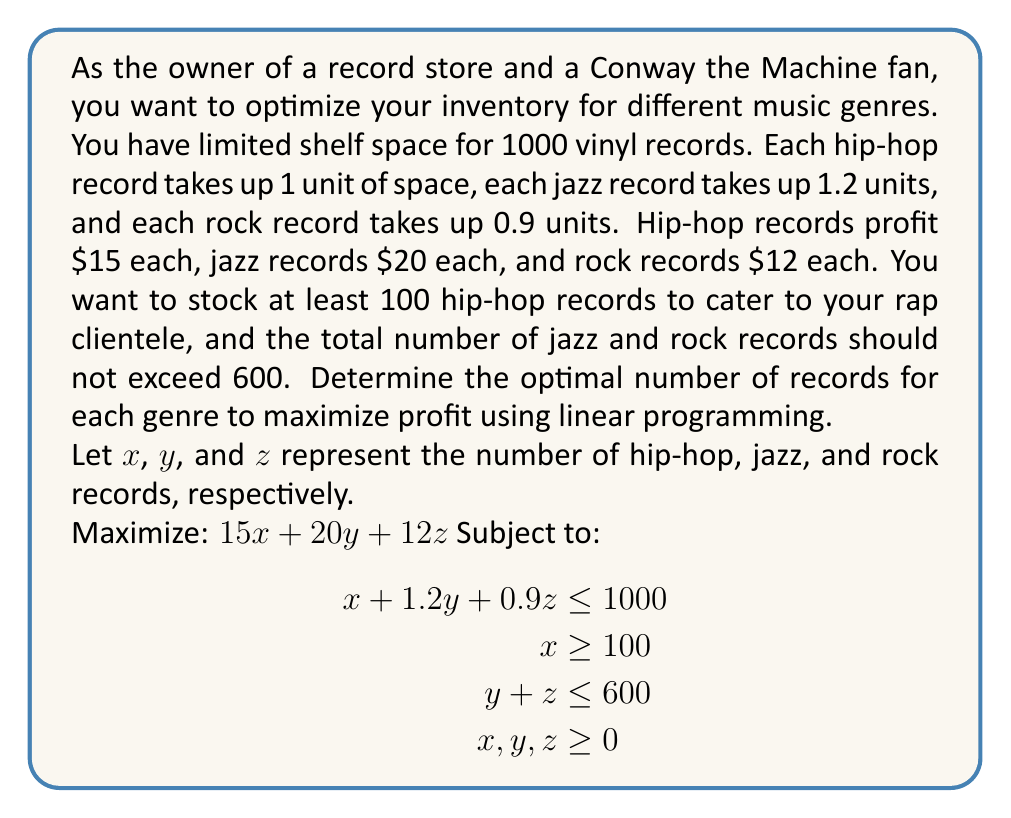Help me with this question. To solve this linear programming problem, we'll use the simplex method:

1. Convert inequalities to equations by introducing slack variables:
   $$\begin{align}
   x + 1.2y + 0.9z + s_1 &= 1000 \\
   x - s_2 &= 100 \\
   y + z + s_3 &= 600 \\
   x, y, z, s_1, s_2, s_3 &\geq 0
   \end{align}$$

2. Set up the initial tableau:
   $$\begin{array}{c|cccccc|c}
   & x & y & z & s_1 & s_2 & s_3 & \text{RHS} \\
   \hline
   s_1 & 1 & 1.2 & 0.9 & 1 & 0 & 0 & 1000 \\
   s_2 & -1 & 0 & 0 & 0 & 1 & 0 & -100 \\
   s_3 & 0 & 1 & 1 & 0 & 0 & 1 & 600 \\
   \hline
   z & -15 & -20 & -12 & 0 & 0 & 0 & 0
   \end{array}$$

3. Perform pivot operations:
   a. Select y as the entering variable (most negative in z-row)
   b. Select s_1 as the leaving variable (minimum ratio test)
   c. Pivot on the intersection of y-column and s_1-row

4. Continue pivoting until no negative values remain in the z-row

5. Final tableau:
   $$\begin{array}{c|cccccc|c}
   & x & y & z & s_1 & s_2 & s_3 & \text{RHS} \\
   \hline
   y & 0.833 & 1 & 0 & 0.833 & 0 & -0.75 & 500 \\
   x & 1 & 0 & 0 & 0 & 1 & 0 & 100 \\
   z & -0.75 & 0 & 1 & -0.75 & 0 & 0.75 & 450 \\
   \hline
   z & 0 & 0 & 0 & 5 & 0 & 15 & 17500
   \end{array}$$

6. Read the optimal solution:
   x = 100 (hip-hop records)
   y = 500 (jazz records)
   z = 450 (rock records)

7. Calculate the maximum profit:
   $15(100) + 20(500) + 12(450) = 17500$
Answer: The optimal inventory levels are 100 hip-hop records, 500 jazz records, and 450 rock records, resulting in a maximum profit of $17,500. 